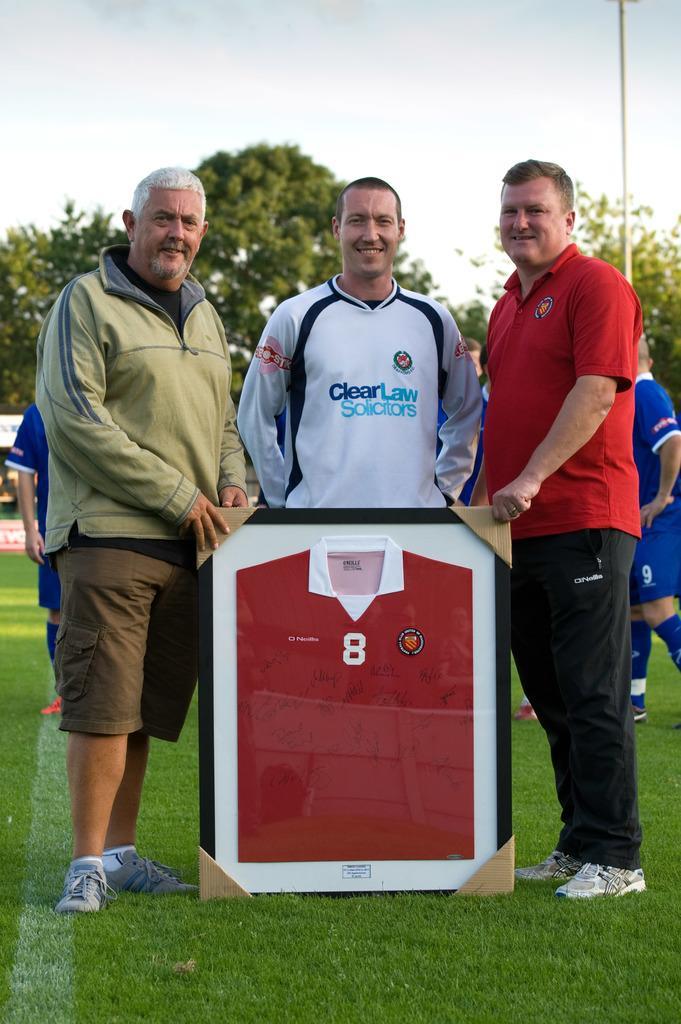Could you give a brief overview of what you see in this image? In the image we can see three men standing, they are wearing clothes and shoes. This is a frame, grass, trees and sky. Behind them there are people walking. 